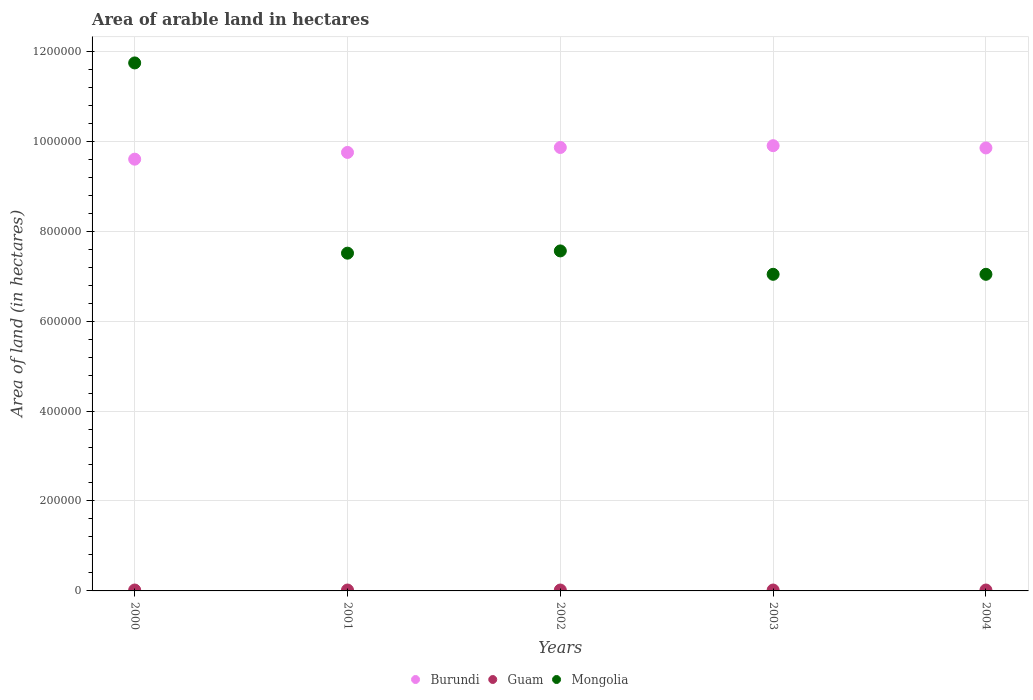Is the number of dotlines equal to the number of legend labels?
Make the answer very short. Yes. What is the total arable land in Burundi in 2003?
Your answer should be compact. 9.90e+05. Across all years, what is the maximum total arable land in Burundi?
Offer a very short reply. 9.90e+05. Across all years, what is the minimum total arable land in Burundi?
Ensure brevity in your answer.  9.60e+05. In which year was the total arable land in Guam minimum?
Give a very brief answer. 2000. What is the total total arable land in Burundi in the graph?
Keep it short and to the point. 4.90e+06. What is the difference between the total arable land in Mongolia in 2001 and that in 2002?
Your answer should be compact. -5000. What is the difference between the total arable land in Guam in 2002 and the total arable land in Mongolia in 2001?
Offer a terse response. -7.49e+05. What is the average total arable land in Burundi per year?
Ensure brevity in your answer.  9.79e+05. In the year 2002, what is the difference between the total arable land in Burundi and total arable land in Guam?
Your answer should be very brief. 9.84e+05. In how many years, is the total arable land in Guam greater than 1000000 hectares?
Offer a terse response. 0. What is the ratio of the total arable land in Burundi in 2002 to that in 2003?
Make the answer very short. 1. What is the difference between the highest and the second highest total arable land in Burundi?
Offer a very short reply. 4000. What is the difference between the highest and the lowest total arable land in Burundi?
Your response must be concise. 3.00e+04. In how many years, is the total arable land in Burundi greater than the average total arable land in Burundi taken over all years?
Offer a terse response. 3. Is the sum of the total arable land in Guam in 2003 and 2004 greater than the maximum total arable land in Burundi across all years?
Offer a terse response. No. Is it the case that in every year, the sum of the total arable land in Burundi and total arable land in Guam  is greater than the total arable land in Mongolia?
Provide a short and direct response. No. Does the total arable land in Guam monotonically increase over the years?
Keep it short and to the point. No. Is the total arable land in Burundi strictly less than the total arable land in Guam over the years?
Give a very brief answer. No. How many years are there in the graph?
Give a very brief answer. 5. What is the title of the graph?
Ensure brevity in your answer.  Area of arable land in hectares. Does "Austria" appear as one of the legend labels in the graph?
Provide a succinct answer. No. What is the label or title of the X-axis?
Your answer should be compact. Years. What is the label or title of the Y-axis?
Keep it short and to the point. Area of land (in hectares). What is the Area of land (in hectares) in Burundi in 2000?
Your response must be concise. 9.60e+05. What is the Area of land (in hectares) in Mongolia in 2000?
Give a very brief answer. 1.17e+06. What is the Area of land (in hectares) of Burundi in 2001?
Provide a succinct answer. 9.75e+05. What is the Area of land (in hectares) of Guam in 2001?
Your answer should be very brief. 2000. What is the Area of land (in hectares) of Mongolia in 2001?
Offer a terse response. 7.51e+05. What is the Area of land (in hectares) of Burundi in 2002?
Keep it short and to the point. 9.86e+05. What is the Area of land (in hectares) in Guam in 2002?
Keep it short and to the point. 2000. What is the Area of land (in hectares) of Mongolia in 2002?
Your response must be concise. 7.56e+05. What is the Area of land (in hectares) in Burundi in 2003?
Keep it short and to the point. 9.90e+05. What is the Area of land (in hectares) in Mongolia in 2003?
Ensure brevity in your answer.  7.04e+05. What is the Area of land (in hectares) of Burundi in 2004?
Offer a very short reply. 9.85e+05. What is the Area of land (in hectares) of Guam in 2004?
Make the answer very short. 2000. What is the Area of land (in hectares) in Mongolia in 2004?
Offer a very short reply. 7.04e+05. Across all years, what is the maximum Area of land (in hectares) in Burundi?
Your answer should be compact. 9.90e+05. Across all years, what is the maximum Area of land (in hectares) of Mongolia?
Offer a terse response. 1.17e+06. Across all years, what is the minimum Area of land (in hectares) of Burundi?
Ensure brevity in your answer.  9.60e+05. Across all years, what is the minimum Area of land (in hectares) of Mongolia?
Provide a succinct answer. 7.04e+05. What is the total Area of land (in hectares) in Burundi in the graph?
Keep it short and to the point. 4.90e+06. What is the total Area of land (in hectares) in Guam in the graph?
Your answer should be very brief. 10000. What is the total Area of land (in hectares) in Mongolia in the graph?
Provide a succinct answer. 4.09e+06. What is the difference between the Area of land (in hectares) of Burundi in 2000 and that in 2001?
Offer a very short reply. -1.50e+04. What is the difference between the Area of land (in hectares) in Guam in 2000 and that in 2001?
Your answer should be compact. 0. What is the difference between the Area of land (in hectares) of Mongolia in 2000 and that in 2001?
Keep it short and to the point. 4.23e+05. What is the difference between the Area of land (in hectares) in Burundi in 2000 and that in 2002?
Provide a succinct answer. -2.60e+04. What is the difference between the Area of land (in hectares) in Guam in 2000 and that in 2002?
Give a very brief answer. 0. What is the difference between the Area of land (in hectares) in Mongolia in 2000 and that in 2002?
Your response must be concise. 4.18e+05. What is the difference between the Area of land (in hectares) in Burundi in 2000 and that in 2003?
Your answer should be very brief. -3.00e+04. What is the difference between the Area of land (in hectares) in Guam in 2000 and that in 2003?
Your response must be concise. 0. What is the difference between the Area of land (in hectares) of Mongolia in 2000 and that in 2003?
Ensure brevity in your answer.  4.70e+05. What is the difference between the Area of land (in hectares) in Burundi in 2000 and that in 2004?
Your answer should be compact. -2.50e+04. What is the difference between the Area of land (in hectares) of Burundi in 2001 and that in 2002?
Your answer should be compact. -1.10e+04. What is the difference between the Area of land (in hectares) of Mongolia in 2001 and that in 2002?
Make the answer very short. -5000. What is the difference between the Area of land (in hectares) of Burundi in 2001 and that in 2003?
Make the answer very short. -1.50e+04. What is the difference between the Area of land (in hectares) of Guam in 2001 and that in 2003?
Keep it short and to the point. 0. What is the difference between the Area of land (in hectares) in Mongolia in 2001 and that in 2003?
Offer a terse response. 4.70e+04. What is the difference between the Area of land (in hectares) in Mongolia in 2001 and that in 2004?
Your answer should be compact. 4.70e+04. What is the difference between the Area of land (in hectares) in Burundi in 2002 and that in 2003?
Your answer should be compact. -4000. What is the difference between the Area of land (in hectares) in Mongolia in 2002 and that in 2003?
Offer a very short reply. 5.20e+04. What is the difference between the Area of land (in hectares) in Burundi in 2002 and that in 2004?
Give a very brief answer. 1000. What is the difference between the Area of land (in hectares) of Guam in 2002 and that in 2004?
Ensure brevity in your answer.  0. What is the difference between the Area of land (in hectares) of Mongolia in 2002 and that in 2004?
Your answer should be very brief. 5.20e+04. What is the difference between the Area of land (in hectares) in Burundi in 2003 and that in 2004?
Provide a succinct answer. 5000. What is the difference between the Area of land (in hectares) in Mongolia in 2003 and that in 2004?
Your answer should be compact. 0. What is the difference between the Area of land (in hectares) of Burundi in 2000 and the Area of land (in hectares) of Guam in 2001?
Your answer should be compact. 9.58e+05. What is the difference between the Area of land (in hectares) in Burundi in 2000 and the Area of land (in hectares) in Mongolia in 2001?
Your response must be concise. 2.09e+05. What is the difference between the Area of land (in hectares) in Guam in 2000 and the Area of land (in hectares) in Mongolia in 2001?
Keep it short and to the point. -7.49e+05. What is the difference between the Area of land (in hectares) in Burundi in 2000 and the Area of land (in hectares) in Guam in 2002?
Keep it short and to the point. 9.58e+05. What is the difference between the Area of land (in hectares) in Burundi in 2000 and the Area of land (in hectares) in Mongolia in 2002?
Provide a short and direct response. 2.04e+05. What is the difference between the Area of land (in hectares) of Guam in 2000 and the Area of land (in hectares) of Mongolia in 2002?
Your answer should be compact. -7.54e+05. What is the difference between the Area of land (in hectares) of Burundi in 2000 and the Area of land (in hectares) of Guam in 2003?
Ensure brevity in your answer.  9.58e+05. What is the difference between the Area of land (in hectares) of Burundi in 2000 and the Area of land (in hectares) of Mongolia in 2003?
Your answer should be compact. 2.56e+05. What is the difference between the Area of land (in hectares) of Guam in 2000 and the Area of land (in hectares) of Mongolia in 2003?
Provide a succinct answer. -7.02e+05. What is the difference between the Area of land (in hectares) in Burundi in 2000 and the Area of land (in hectares) in Guam in 2004?
Your answer should be very brief. 9.58e+05. What is the difference between the Area of land (in hectares) in Burundi in 2000 and the Area of land (in hectares) in Mongolia in 2004?
Offer a terse response. 2.56e+05. What is the difference between the Area of land (in hectares) of Guam in 2000 and the Area of land (in hectares) of Mongolia in 2004?
Keep it short and to the point. -7.02e+05. What is the difference between the Area of land (in hectares) of Burundi in 2001 and the Area of land (in hectares) of Guam in 2002?
Your answer should be very brief. 9.73e+05. What is the difference between the Area of land (in hectares) of Burundi in 2001 and the Area of land (in hectares) of Mongolia in 2002?
Offer a terse response. 2.19e+05. What is the difference between the Area of land (in hectares) of Guam in 2001 and the Area of land (in hectares) of Mongolia in 2002?
Give a very brief answer. -7.54e+05. What is the difference between the Area of land (in hectares) of Burundi in 2001 and the Area of land (in hectares) of Guam in 2003?
Keep it short and to the point. 9.73e+05. What is the difference between the Area of land (in hectares) of Burundi in 2001 and the Area of land (in hectares) of Mongolia in 2003?
Offer a very short reply. 2.71e+05. What is the difference between the Area of land (in hectares) in Guam in 2001 and the Area of land (in hectares) in Mongolia in 2003?
Offer a very short reply. -7.02e+05. What is the difference between the Area of land (in hectares) of Burundi in 2001 and the Area of land (in hectares) of Guam in 2004?
Ensure brevity in your answer.  9.73e+05. What is the difference between the Area of land (in hectares) in Burundi in 2001 and the Area of land (in hectares) in Mongolia in 2004?
Your answer should be compact. 2.71e+05. What is the difference between the Area of land (in hectares) in Guam in 2001 and the Area of land (in hectares) in Mongolia in 2004?
Provide a short and direct response. -7.02e+05. What is the difference between the Area of land (in hectares) of Burundi in 2002 and the Area of land (in hectares) of Guam in 2003?
Offer a very short reply. 9.84e+05. What is the difference between the Area of land (in hectares) of Burundi in 2002 and the Area of land (in hectares) of Mongolia in 2003?
Offer a very short reply. 2.82e+05. What is the difference between the Area of land (in hectares) in Guam in 2002 and the Area of land (in hectares) in Mongolia in 2003?
Give a very brief answer. -7.02e+05. What is the difference between the Area of land (in hectares) in Burundi in 2002 and the Area of land (in hectares) in Guam in 2004?
Your answer should be very brief. 9.84e+05. What is the difference between the Area of land (in hectares) in Burundi in 2002 and the Area of land (in hectares) in Mongolia in 2004?
Keep it short and to the point. 2.82e+05. What is the difference between the Area of land (in hectares) of Guam in 2002 and the Area of land (in hectares) of Mongolia in 2004?
Offer a terse response. -7.02e+05. What is the difference between the Area of land (in hectares) of Burundi in 2003 and the Area of land (in hectares) of Guam in 2004?
Provide a succinct answer. 9.88e+05. What is the difference between the Area of land (in hectares) in Burundi in 2003 and the Area of land (in hectares) in Mongolia in 2004?
Your response must be concise. 2.86e+05. What is the difference between the Area of land (in hectares) of Guam in 2003 and the Area of land (in hectares) of Mongolia in 2004?
Your answer should be very brief. -7.02e+05. What is the average Area of land (in hectares) in Burundi per year?
Ensure brevity in your answer.  9.79e+05. What is the average Area of land (in hectares) of Mongolia per year?
Provide a succinct answer. 8.18e+05. In the year 2000, what is the difference between the Area of land (in hectares) in Burundi and Area of land (in hectares) in Guam?
Offer a terse response. 9.58e+05. In the year 2000, what is the difference between the Area of land (in hectares) in Burundi and Area of land (in hectares) in Mongolia?
Offer a terse response. -2.14e+05. In the year 2000, what is the difference between the Area of land (in hectares) in Guam and Area of land (in hectares) in Mongolia?
Your answer should be very brief. -1.17e+06. In the year 2001, what is the difference between the Area of land (in hectares) in Burundi and Area of land (in hectares) in Guam?
Ensure brevity in your answer.  9.73e+05. In the year 2001, what is the difference between the Area of land (in hectares) of Burundi and Area of land (in hectares) of Mongolia?
Offer a very short reply. 2.24e+05. In the year 2001, what is the difference between the Area of land (in hectares) of Guam and Area of land (in hectares) of Mongolia?
Offer a very short reply. -7.49e+05. In the year 2002, what is the difference between the Area of land (in hectares) of Burundi and Area of land (in hectares) of Guam?
Your answer should be very brief. 9.84e+05. In the year 2002, what is the difference between the Area of land (in hectares) of Guam and Area of land (in hectares) of Mongolia?
Give a very brief answer. -7.54e+05. In the year 2003, what is the difference between the Area of land (in hectares) of Burundi and Area of land (in hectares) of Guam?
Provide a short and direct response. 9.88e+05. In the year 2003, what is the difference between the Area of land (in hectares) in Burundi and Area of land (in hectares) in Mongolia?
Your answer should be compact. 2.86e+05. In the year 2003, what is the difference between the Area of land (in hectares) of Guam and Area of land (in hectares) of Mongolia?
Provide a succinct answer. -7.02e+05. In the year 2004, what is the difference between the Area of land (in hectares) of Burundi and Area of land (in hectares) of Guam?
Offer a very short reply. 9.83e+05. In the year 2004, what is the difference between the Area of land (in hectares) in Burundi and Area of land (in hectares) in Mongolia?
Make the answer very short. 2.81e+05. In the year 2004, what is the difference between the Area of land (in hectares) of Guam and Area of land (in hectares) of Mongolia?
Your answer should be compact. -7.02e+05. What is the ratio of the Area of land (in hectares) in Burundi in 2000 to that in 2001?
Provide a succinct answer. 0.98. What is the ratio of the Area of land (in hectares) of Guam in 2000 to that in 2001?
Make the answer very short. 1. What is the ratio of the Area of land (in hectares) in Mongolia in 2000 to that in 2001?
Offer a very short reply. 1.56. What is the ratio of the Area of land (in hectares) of Burundi in 2000 to that in 2002?
Offer a very short reply. 0.97. What is the ratio of the Area of land (in hectares) of Guam in 2000 to that in 2002?
Your answer should be compact. 1. What is the ratio of the Area of land (in hectares) in Mongolia in 2000 to that in 2002?
Ensure brevity in your answer.  1.55. What is the ratio of the Area of land (in hectares) of Burundi in 2000 to that in 2003?
Your answer should be very brief. 0.97. What is the ratio of the Area of land (in hectares) in Guam in 2000 to that in 2003?
Keep it short and to the point. 1. What is the ratio of the Area of land (in hectares) of Mongolia in 2000 to that in 2003?
Give a very brief answer. 1.67. What is the ratio of the Area of land (in hectares) of Burundi in 2000 to that in 2004?
Provide a succinct answer. 0.97. What is the ratio of the Area of land (in hectares) of Guam in 2000 to that in 2004?
Your answer should be compact. 1. What is the ratio of the Area of land (in hectares) of Mongolia in 2000 to that in 2004?
Provide a succinct answer. 1.67. What is the ratio of the Area of land (in hectares) in Guam in 2001 to that in 2002?
Give a very brief answer. 1. What is the ratio of the Area of land (in hectares) in Mongolia in 2001 to that in 2003?
Give a very brief answer. 1.07. What is the ratio of the Area of land (in hectares) in Guam in 2001 to that in 2004?
Give a very brief answer. 1. What is the ratio of the Area of land (in hectares) in Mongolia in 2001 to that in 2004?
Provide a short and direct response. 1.07. What is the ratio of the Area of land (in hectares) in Burundi in 2002 to that in 2003?
Make the answer very short. 1. What is the ratio of the Area of land (in hectares) in Mongolia in 2002 to that in 2003?
Provide a short and direct response. 1.07. What is the ratio of the Area of land (in hectares) of Burundi in 2002 to that in 2004?
Ensure brevity in your answer.  1. What is the ratio of the Area of land (in hectares) of Mongolia in 2002 to that in 2004?
Ensure brevity in your answer.  1.07. What is the ratio of the Area of land (in hectares) in Burundi in 2003 to that in 2004?
Provide a succinct answer. 1.01. What is the difference between the highest and the second highest Area of land (in hectares) in Burundi?
Offer a very short reply. 4000. What is the difference between the highest and the second highest Area of land (in hectares) in Guam?
Keep it short and to the point. 0. What is the difference between the highest and the second highest Area of land (in hectares) of Mongolia?
Offer a very short reply. 4.18e+05. What is the difference between the highest and the lowest Area of land (in hectares) in Burundi?
Offer a very short reply. 3.00e+04. What is the difference between the highest and the lowest Area of land (in hectares) of Guam?
Make the answer very short. 0. 